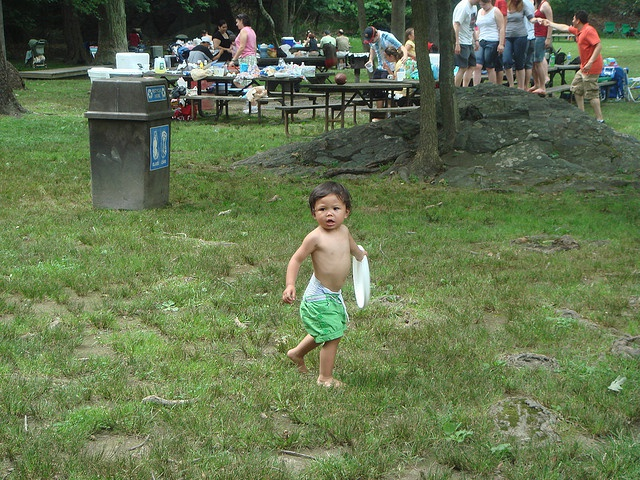Describe the objects in this image and their specific colors. I can see people in black, tan, and gray tones, dining table in black, gray, lightgray, and darkgray tones, people in black, gray, salmon, and brown tones, people in black, gray, ivory, and darkgray tones, and people in black, gray, blue, darkgray, and maroon tones in this image. 